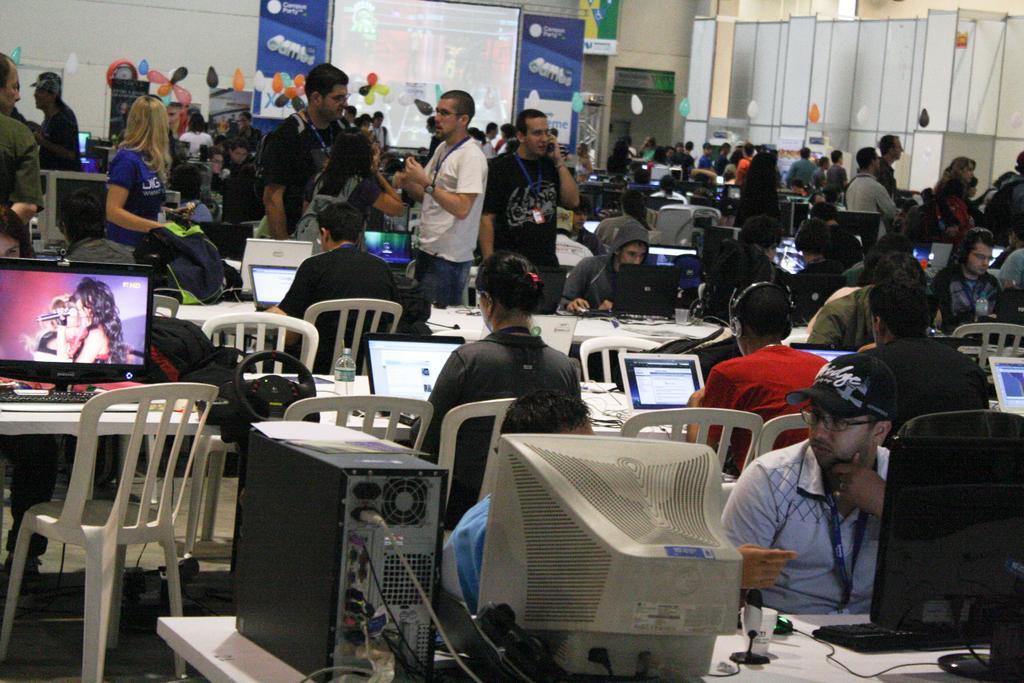Please provide a concise description of this image. The image is taken in the room. The room is filled with tables and chairs. There are many people sitting and standing in the image. There are computers, bottles, bags and wires placed on the tables. In the background there are balloons and boards. In the center of the room there is a screen. 